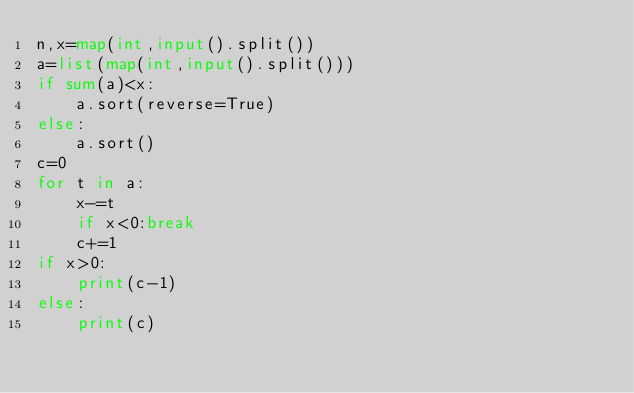<code> <loc_0><loc_0><loc_500><loc_500><_Python_>n,x=map(int,input().split())
a=list(map(int,input().split()))
if sum(a)<x:
    a.sort(reverse=True)
else:
    a.sort()
c=0
for t in a:
    x-=t
    if x<0:break
    c+=1
if x>0:
    print(c-1)
else:
    print(c)</code> 